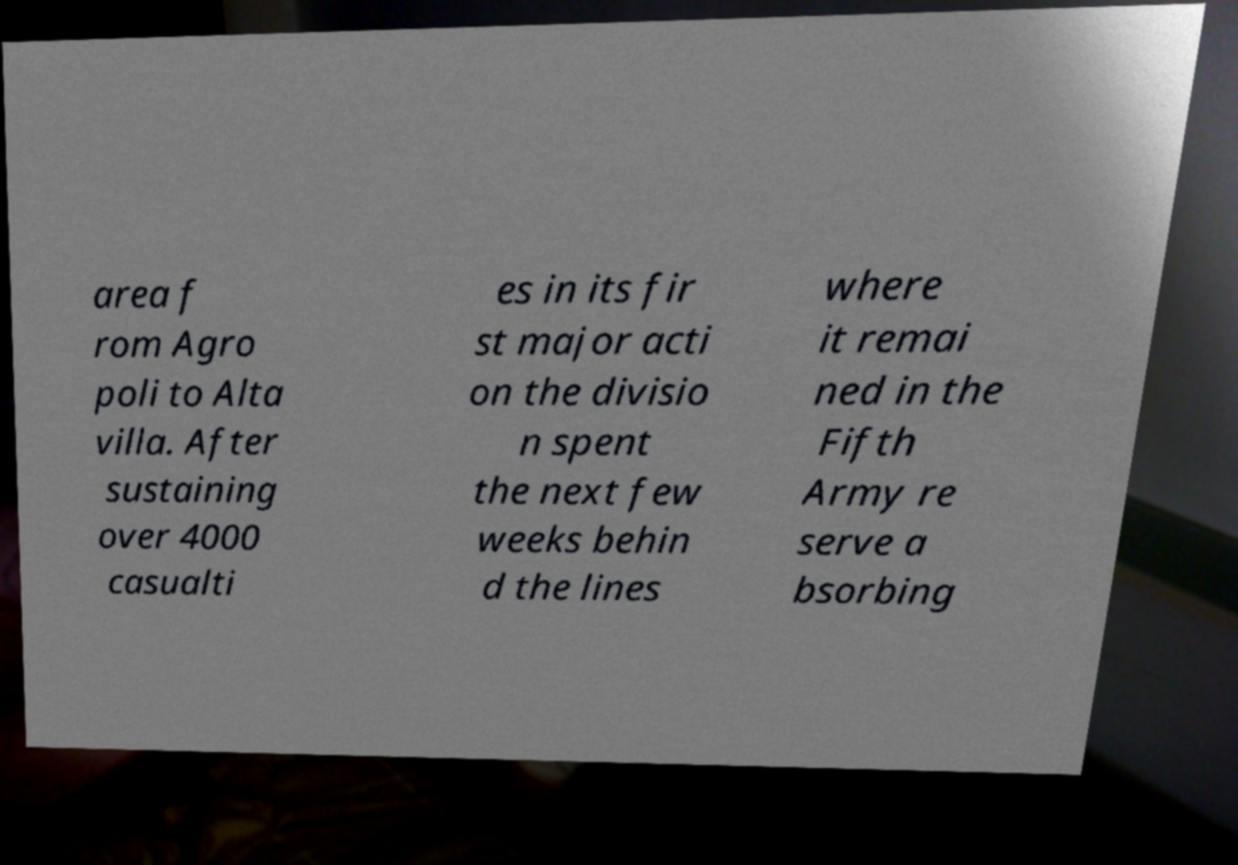I need the written content from this picture converted into text. Can you do that? area f rom Agro poli to Alta villa. After sustaining over 4000 casualti es in its fir st major acti on the divisio n spent the next few weeks behin d the lines where it remai ned in the Fifth Army re serve a bsorbing 